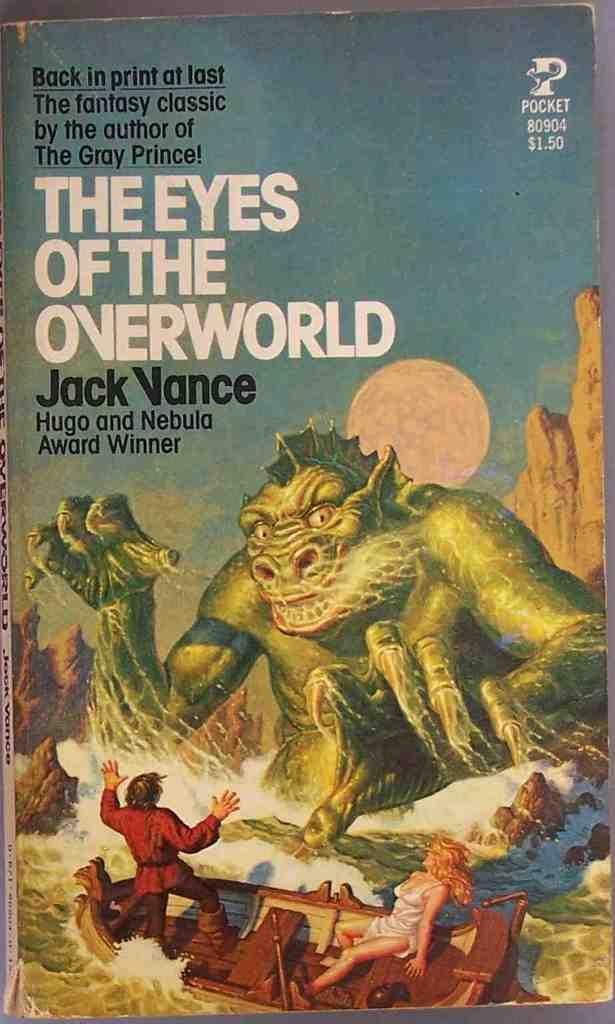<image>
Offer a succinct explanation of the picture presented. $1.50 pocket book the eyes of the overworld by jack vance 